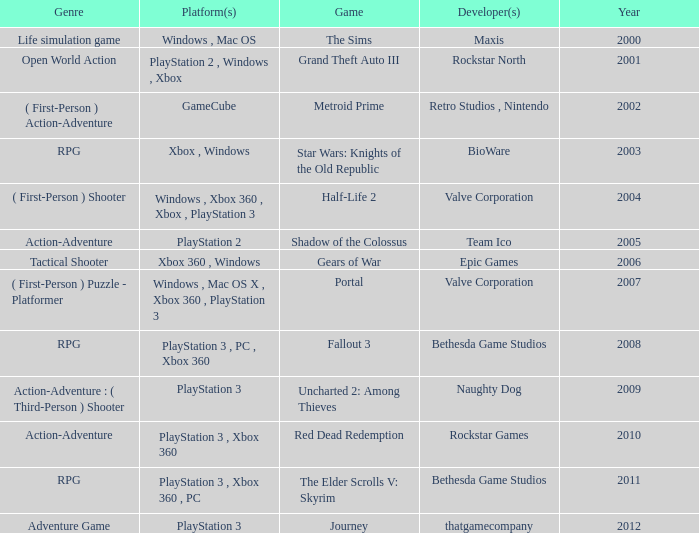What game was in 2001? Grand Theft Auto III. 